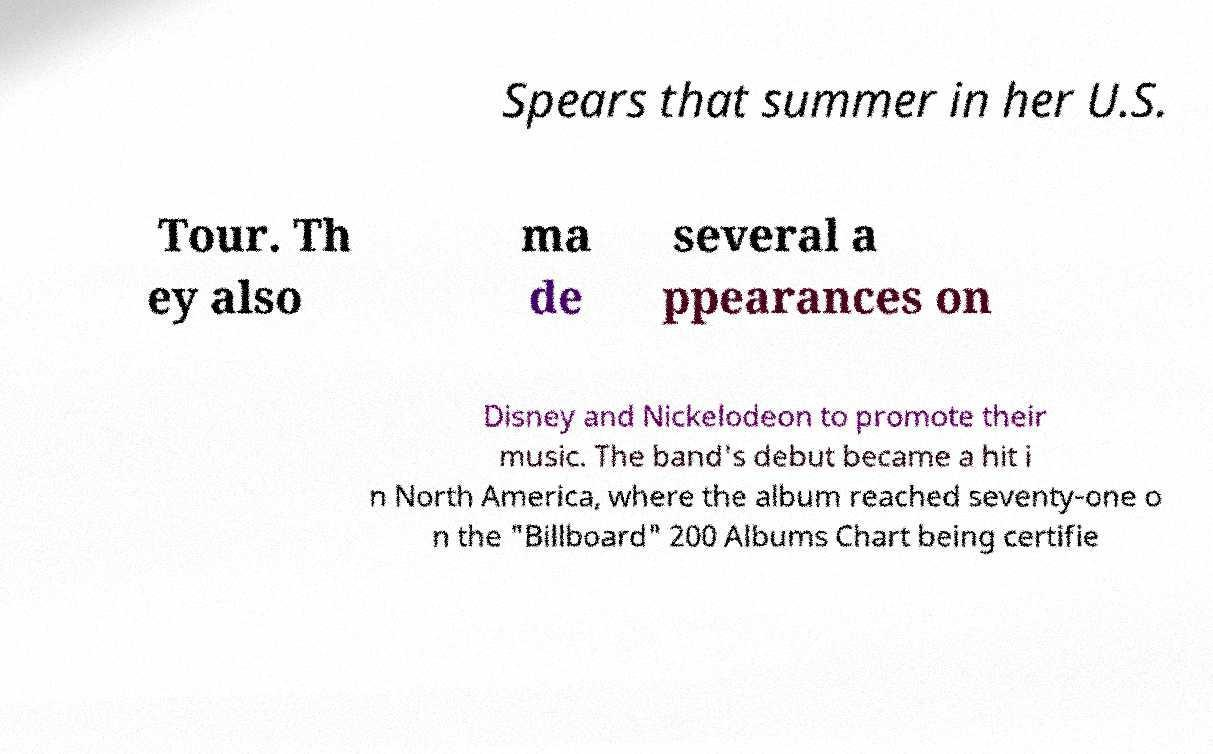There's text embedded in this image that I need extracted. Can you transcribe it verbatim? Spears that summer in her U.S. Tour. Th ey also ma de several a ppearances on Disney and Nickelodeon to promote their music. The band's debut became a hit i n North America, where the album reached seventy-one o n the "Billboard" 200 Albums Chart being certifie 